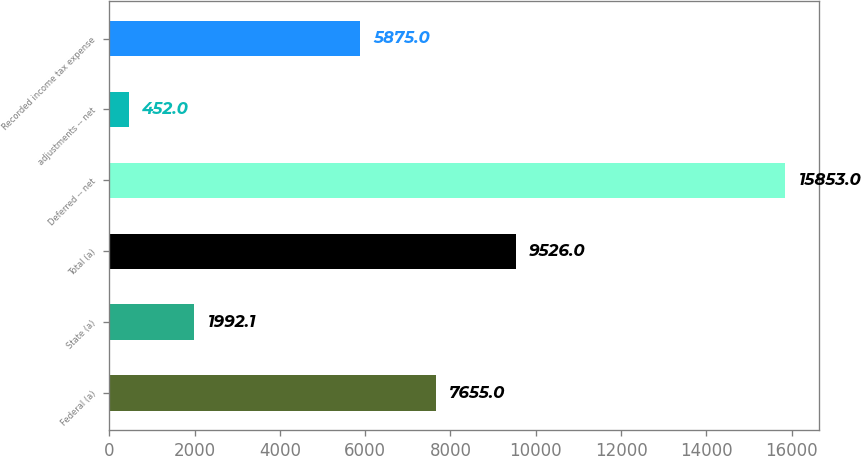<chart> <loc_0><loc_0><loc_500><loc_500><bar_chart><fcel>Federal (a)<fcel>State (a)<fcel>Total (a)<fcel>Deferred -- net<fcel>adjustments -- net<fcel>Recorded income tax expense<nl><fcel>7655<fcel>1992.1<fcel>9526<fcel>15853<fcel>452<fcel>5875<nl></chart> 